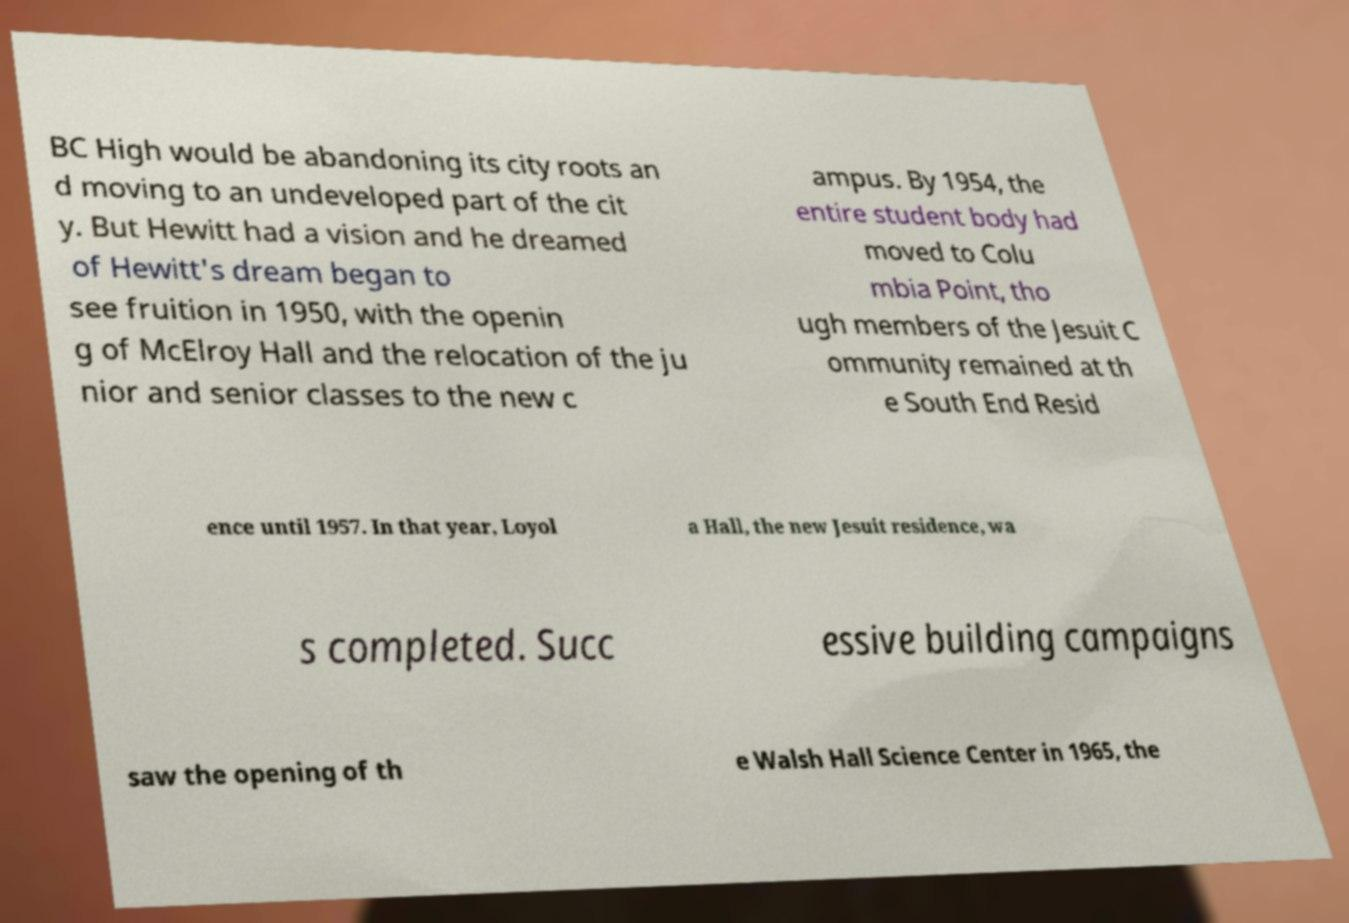Please identify and transcribe the text found in this image. BC High would be abandoning its city roots an d moving to an undeveloped part of the cit y. But Hewitt had a vision and he dreamed of Hewitt's dream began to see fruition in 1950, with the openin g of McElroy Hall and the relocation of the ju nior and senior classes to the new c ampus. By 1954, the entire student body had moved to Colu mbia Point, tho ugh members of the Jesuit C ommunity remained at th e South End Resid ence until 1957. In that year, Loyol a Hall, the new Jesuit residence, wa s completed. Succ essive building campaigns saw the opening of th e Walsh Hall Science Center in 1965, the 